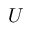<formula> <loc_0><loc_0><loc_500><loc_500>U</formula> 